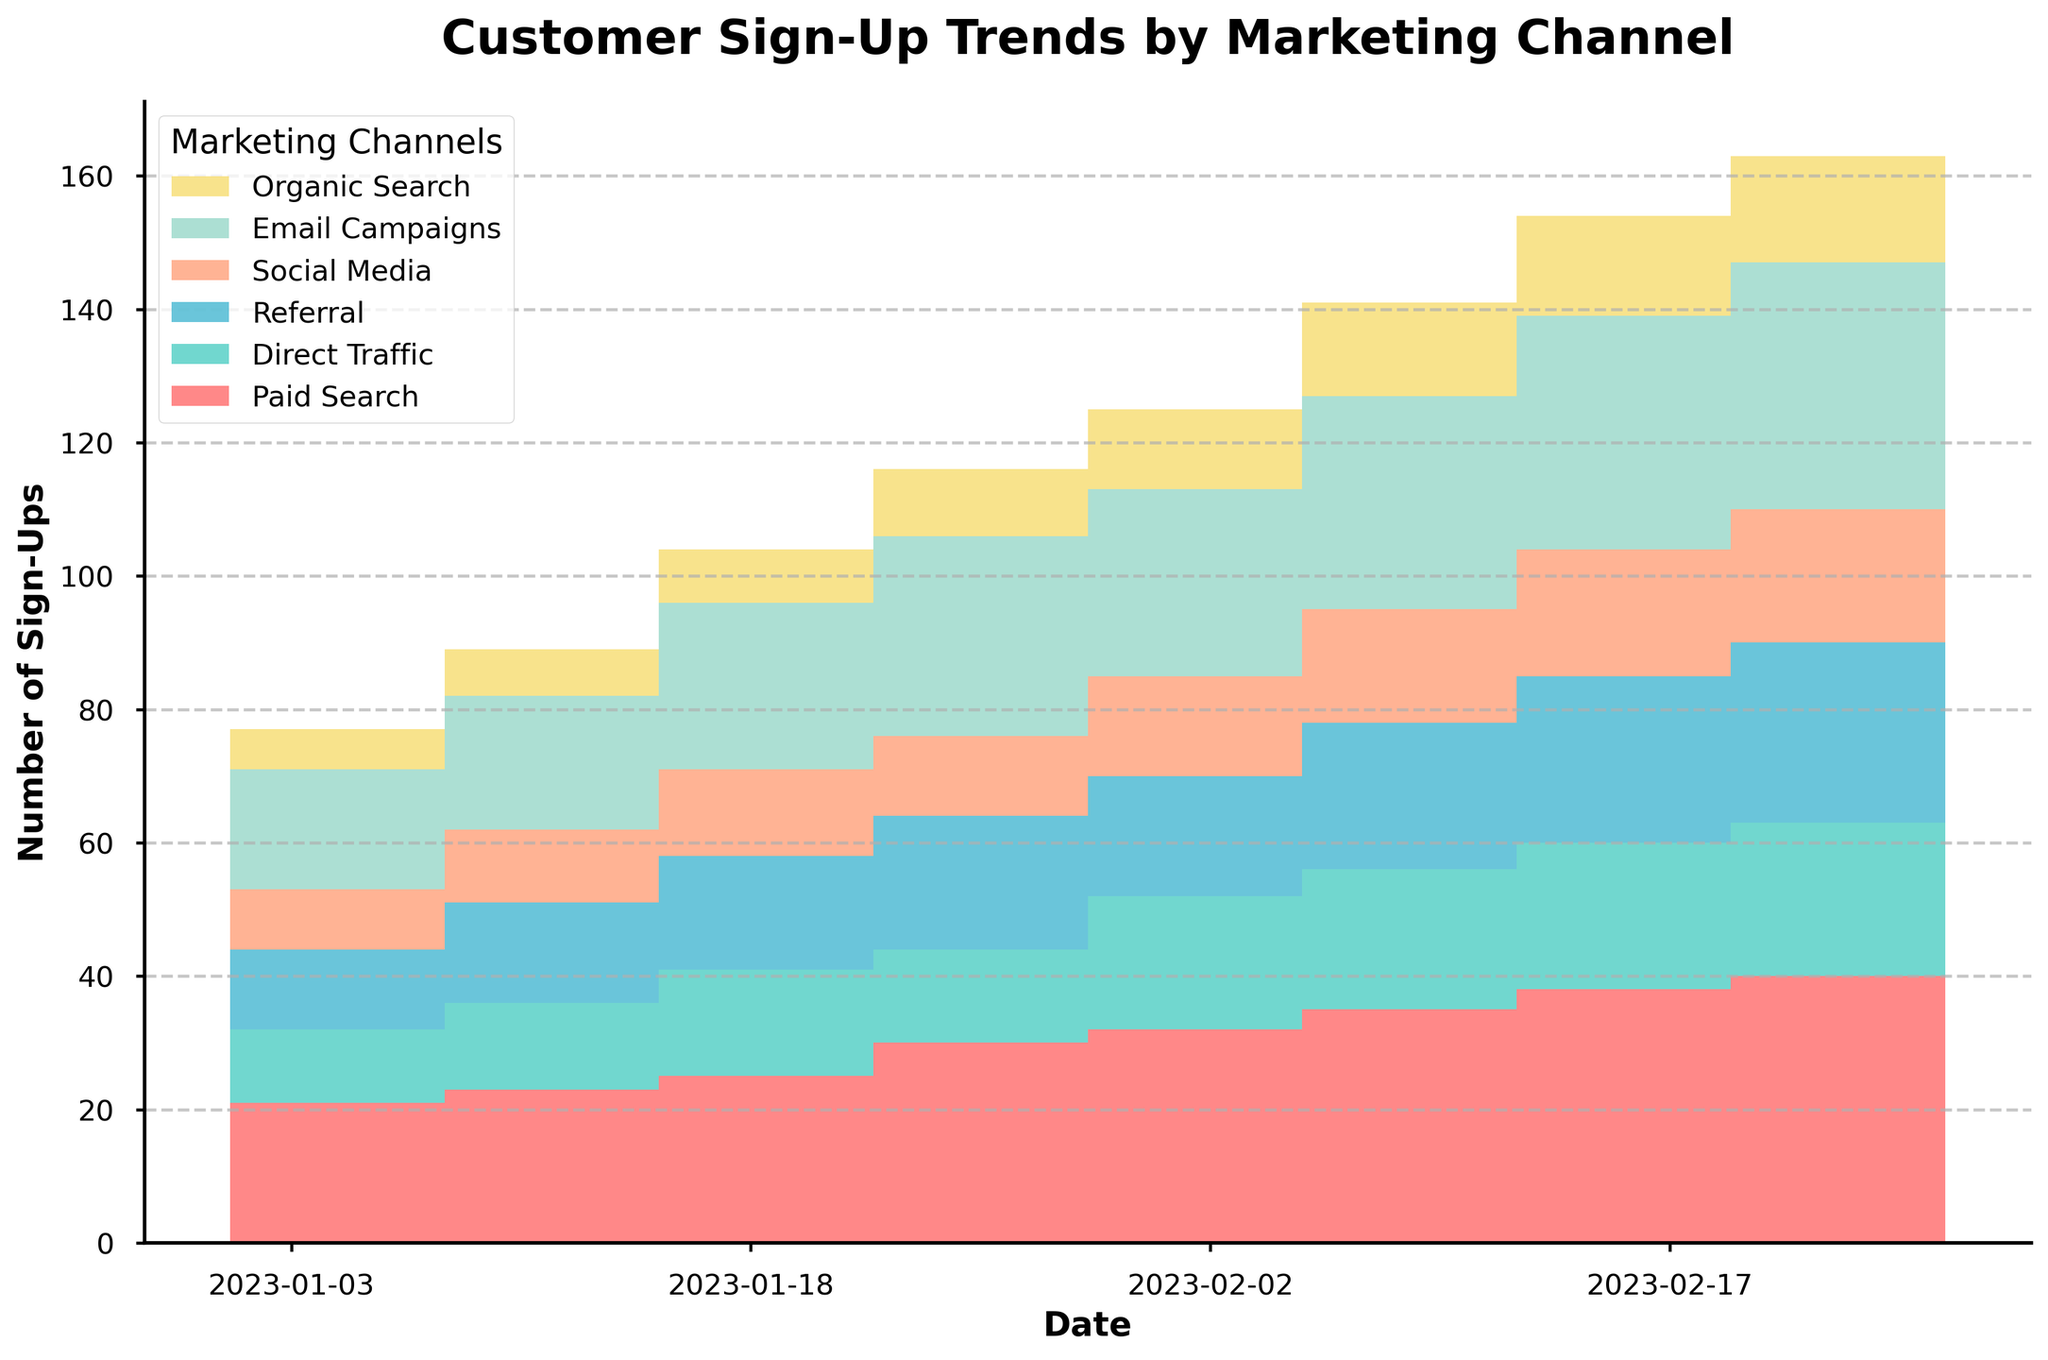What is the title of the step area chart? The title is prominently displayed at the top of the chart. It reads "Customer Sign-Up Trends by Marketing Channel."
Answer: Customer Sign-Up Trends by Marketing Channel What are the labels on the x-axis and y-axis? The labels can be found on the horizontal and vertical axes. The x-axis is labeled "Date," and the y-axis is labeled "Number of Sign-Ups."
Answer: Date and Number of Sign-Ups How many marketing channels are displayed in the chart? The legend shows the marketing channels represented by different colors. There are six channels: Paid Search, Direct Traffic, Referral, Social Media, Email Campaigns, and Organic Search.
Answer: Six Which marketing channel had the highest number of sign-ups on February 26, 2023? By looking at the stacked areas at the rightmost part of the chart, we see that Paid Search occupies the largest area. Therefore, Paid Search had the highest number of sign-ups.
Answer: Paid Search How did the number of sign-ups from Email Campaigns change from January 1 to February 26, 2023? Identify the height of the stacked area corresponding to Email Campaigns on both dates. The number increased from 15 on January 1 to 37 on February 26.
Answer: Increased from 15 to 37 What is the total number of sign-ups from all channels on February 12, 2023? Sum the heights of all the stacked areas on February 12. Email Campaigns: 32, Direct Traffic: 21, Paid Search: 35, etc. The total is 32 + 21 + 22 + 17 + 14 + 35 = 141.
Answer: 141 Which marketing channel showed the most significant growth in sign-ups from January 1 to February 26, 2023? To determine growth, look at the change in the height of the stacked areas from January 1 to February 26. Compare the differences for all channels. Paid Search increased from 20 to 40, which is the largest growth.
Answer: Paid Search What is the overall trend in the total number of sign-ups from January 1 to February 26, 2023? Observing the upper edge of the stacked areas over time, there is a clear upward trend, indicating that the total number of sign-ups is increasing.
Answer: Increasing trend During which week did Referral sign-ups reach their highest point? By tracing the section corresponding to Referral, the tallest point for this channel’s section occurs on February 26.
Answer: February 26, 2023 Compare the social media sign-ups on January 29 and February 19. Which date had higher sign-ups? For Social Media, the stacked area height on January 29 is lower than on February 19. Specifically, Social Media sign-ups were 12 on January 29 and 19 on February 19.
Answer: February 19 